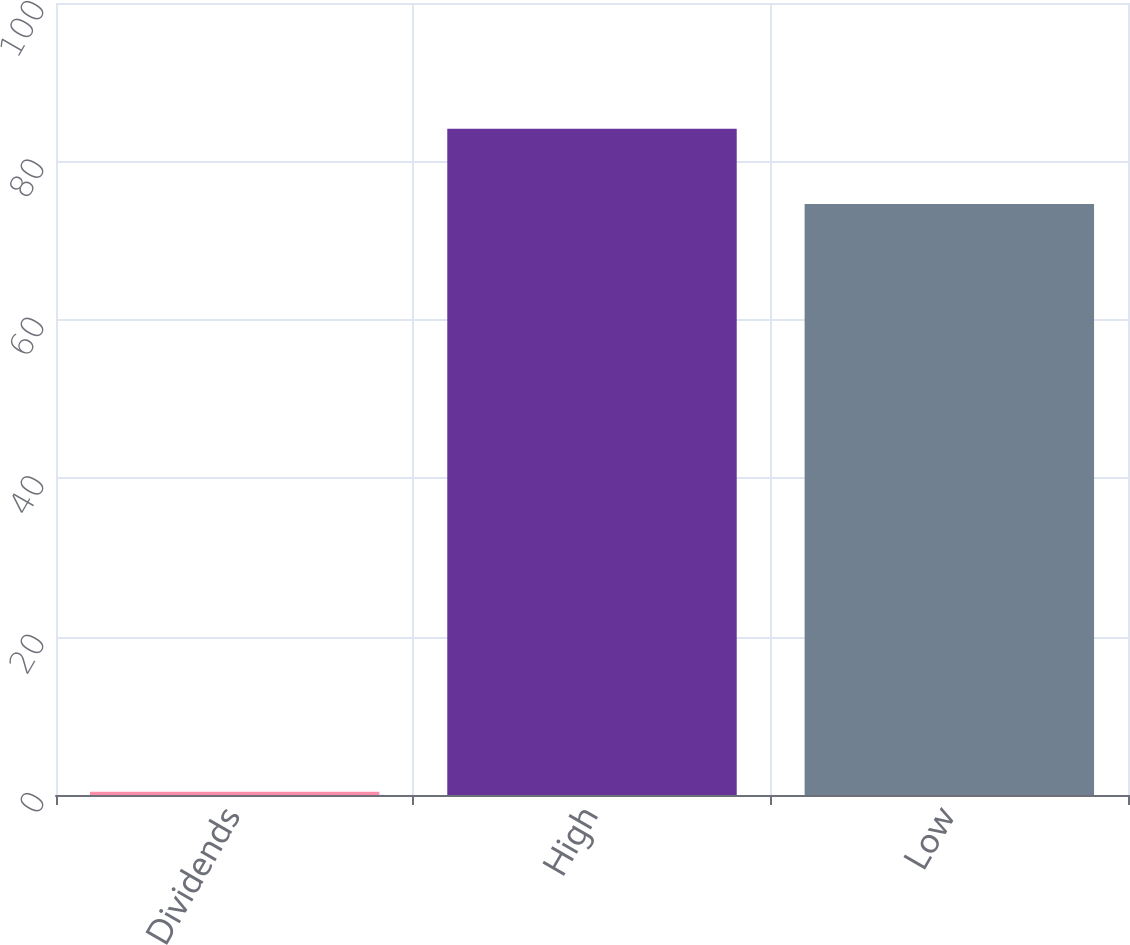Convert chart to OTSL. <chart><loc_0><loc_0><loc_500><loc_500><bar_chart><fcel>Dividends<fcel>High<fcel>Low<nl><fcel>0.4<fcel>84.12<fcel>74.62<nl></chart> 